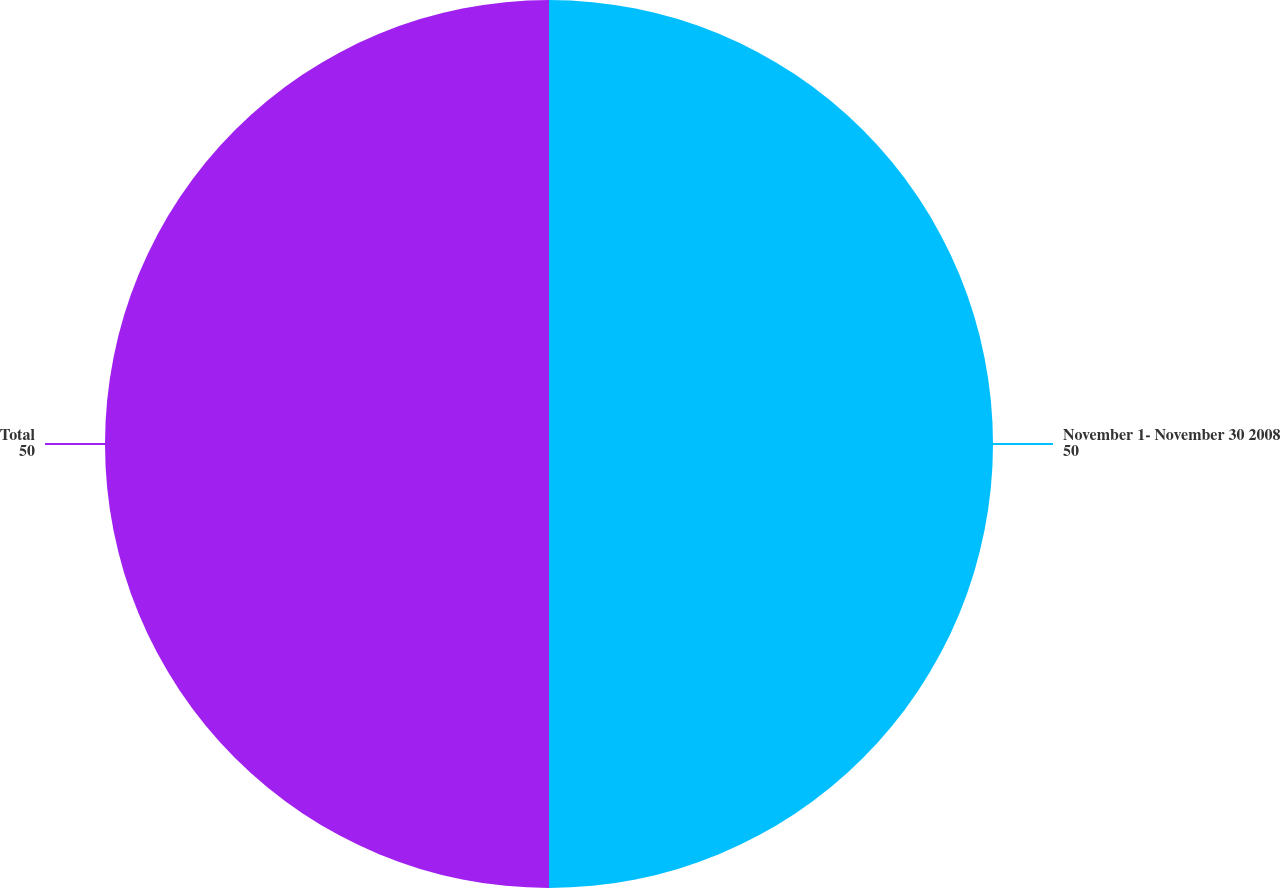<chart> <loc_0><loc_0><loc_500><loc_500><pie_chart><fcel>November 1- November 30 2008<fcel>Total<nl><fcel>50.0%<fcel>50.0%<nl></chart> 